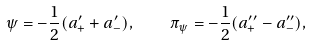Convert formula to latex. <formula><loc_0><loc_0><loc_500><loc_500>\psi = - { \frac { 1 } { 2 } } ( a _ { + } ^ { \prime } + a _ { - } ^ { \prime } ) , \quad \pi _ { \psi } = - { \frac { 1 } { 2 } } ( a _ { + } ^ { \prime \prime } - a _ { - } ^ { \prime \prime } ) ,</formula> 